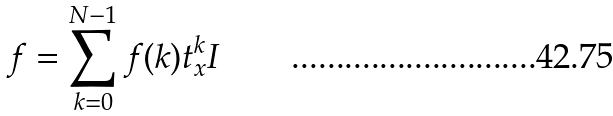<formula> <loc_0><loc_0><loc_500><loc_500>f = \sum _ { k = 0 } ^ { N - 1 } f ( k ) t _ { x } ^ { k } I</formula> 